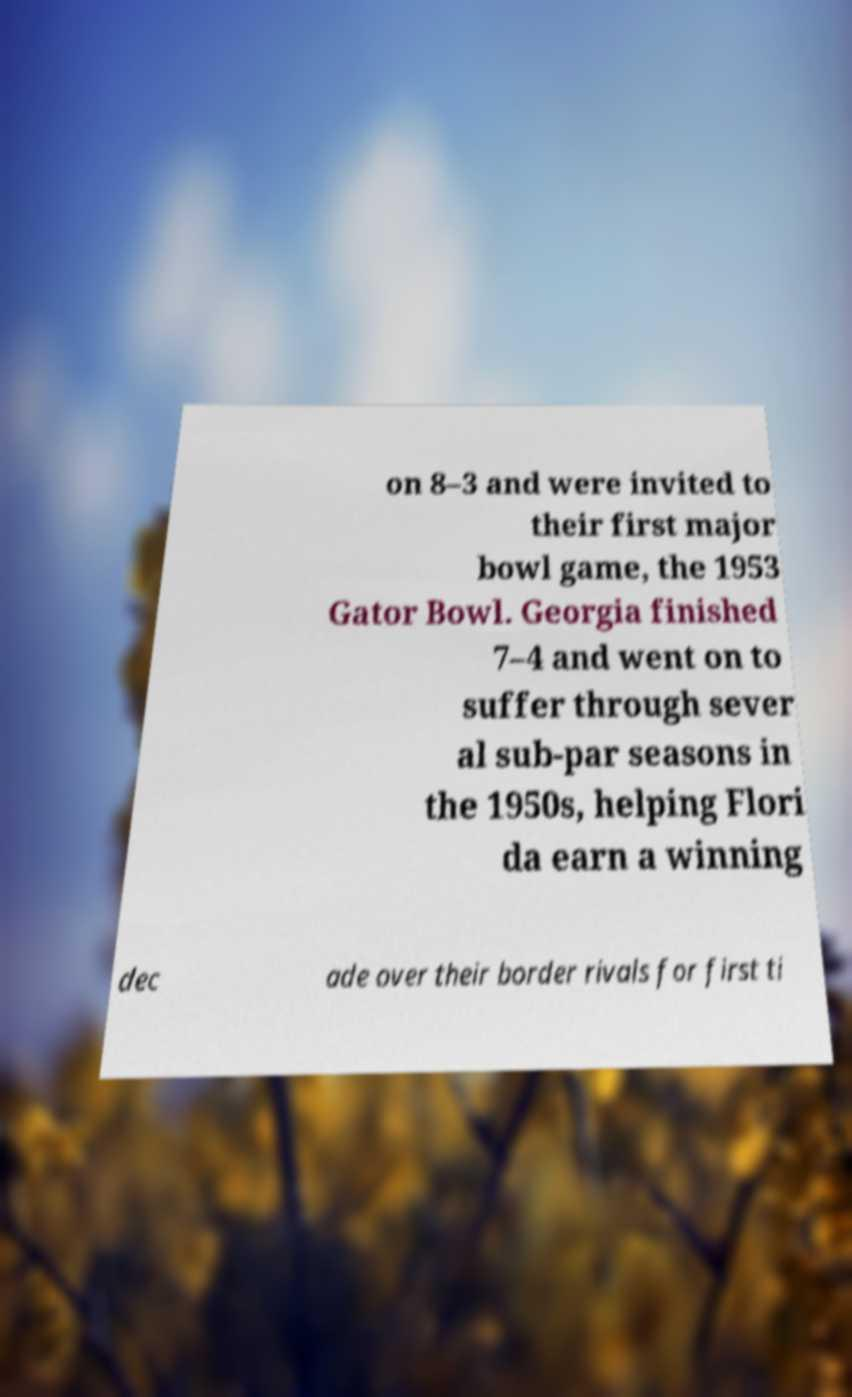Can you read and provide the text displayed in the image?This photo seems to have some interesting text. Can you extract and type it out for me? on 8–3 and were invited to their first major bowl game, the 1953 Gator Bowl. Georgia finished 7–4 and went on to suffer through sever al sub-par seasons in the 1950s, helping Flori da earn a winning dec ade over their border rivals for first ti 